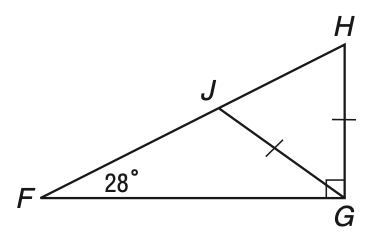Answer the mathemtical geometry problem and directly provide the correct option letter.
Question: In the figure, \triangle F G H is a right triangle with hypotenuse F H and G J = G H. What is the measure of \angle J G H?
Choices: A: 28 B: 56 C: 62 D: 104 B 